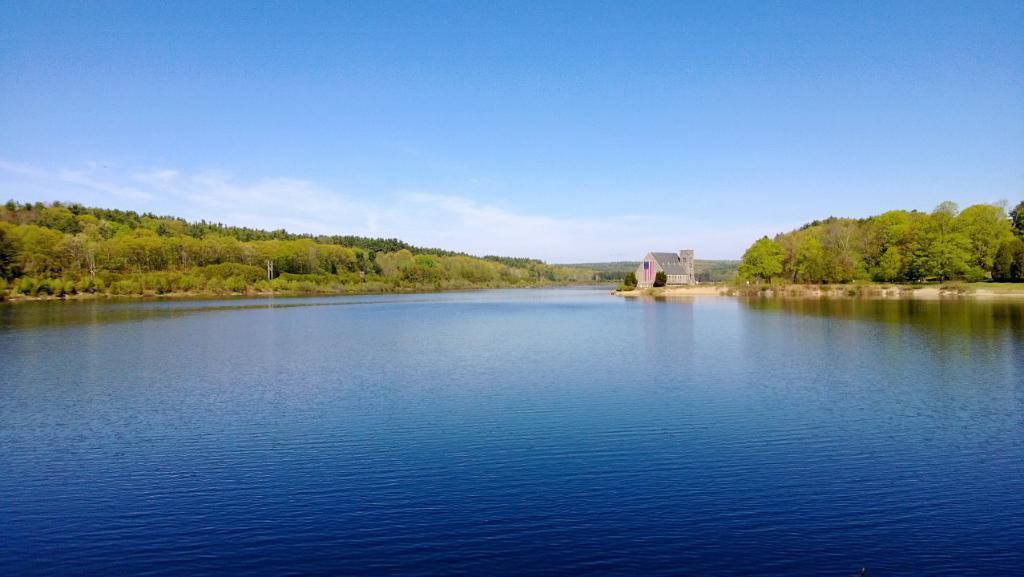Can you describe this image briefly? In this image at the center there is river and at the background there are trees, buildings and sky. 